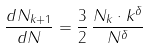Convert formula to latex. <formula><loc_0><loc_0><loc_500><loc_500>\frac { d N _ { k + 1 } } { d N } = \frac { 3 } { 2 } \, \frac { N _ { k } \cdot k ^ { \delta } } { N ^ { \delta } }</formula> 